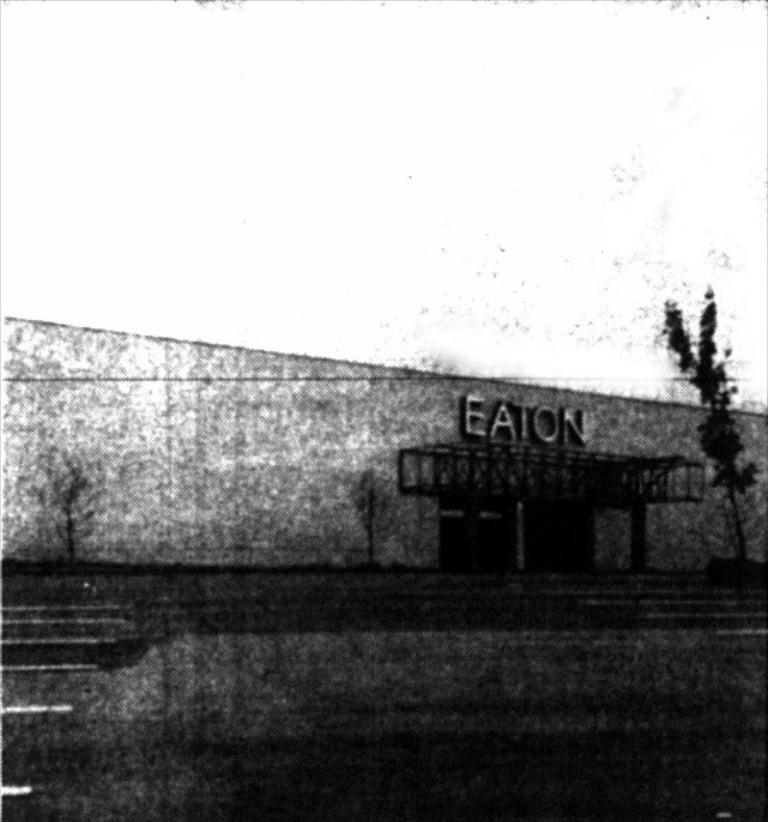 what name is located on the building?
Provide a succinct answer. Eaton. What building is that?
Offer a very short reply. Eaton. 